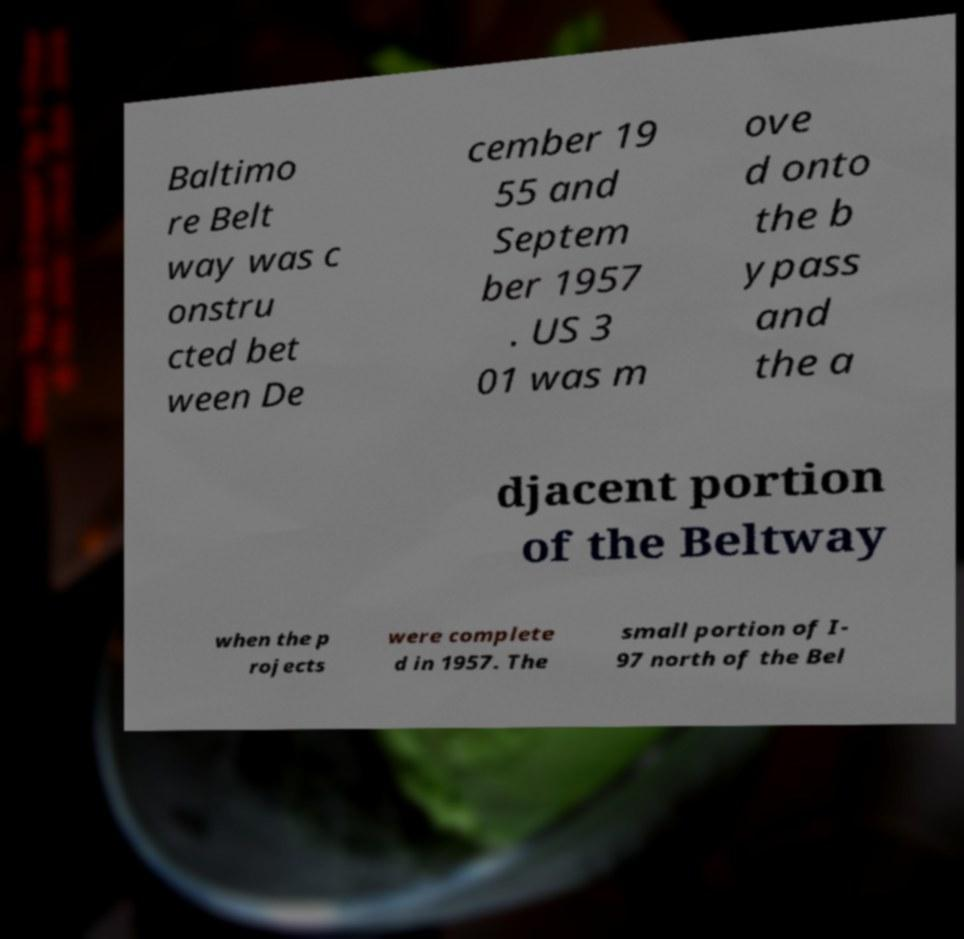For documentation purposes, I need the text within this image transcribed. Could you provide that? Baltimo re Belt way was c onstru cted bet ween De cember 19 55 and Septem ber 1957 . US 3 01 was m ove d onto the b ypass and the a djacent portion of the Beltway when the p rojects were complete d in 1957. The small portion of I- 97 north of the Bel 